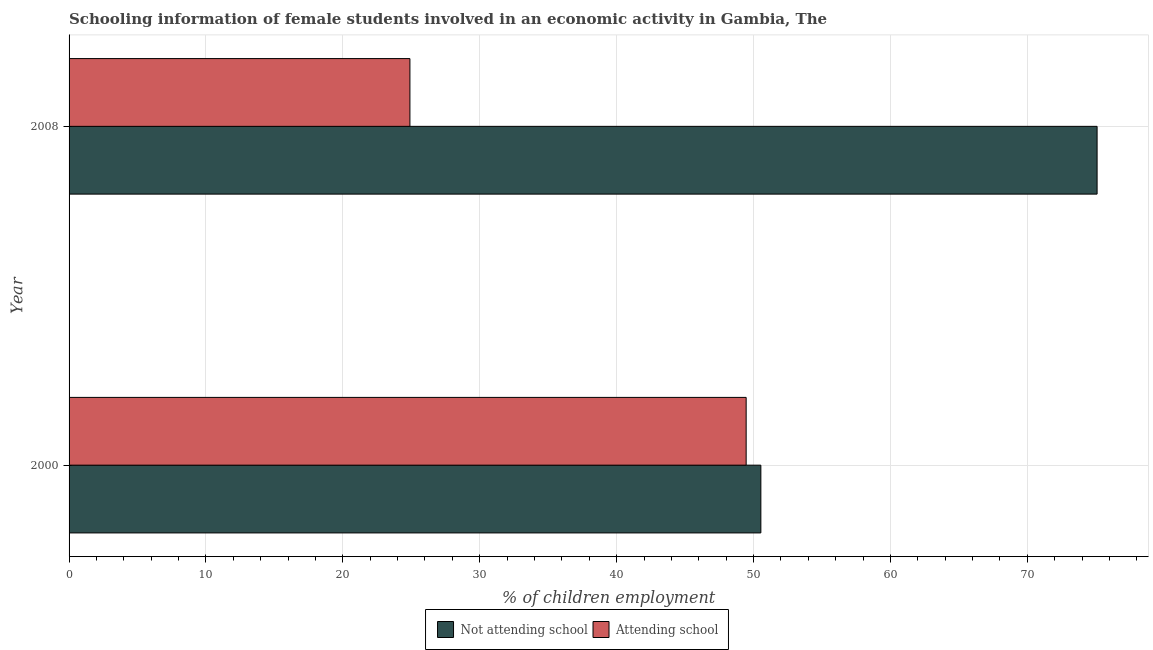How many different coloured bars are there?
Keep it short and to the point. 2. Are the number of bars on each tick of the Y-axis equal?
Offer a very short reply. Yes. How many bars are there on the 1st tick from the top?
Ensure brevity in your answer.  2. In how many cases, is the number of bars for a given year not equal to the number of legend labels?
Provide a short and direct response. 0. What is the percentage of employed females who are attending school in 2000?
Offer a terse response. 49.46. Across all years, what is the maximum percentage of employed females who are attending school?
Give a very brief answer. 49.46. Across all years, what is the minimum percentage of employed females who are not attending school?
Provide a short and direct response. 50.54. In which year was the percentage of employed females who are not attending school maximum?
Offer a very short reply. 2008. In which year was the percentage of employed females who are attending school minimum?
Ensure brevity in your answer.  2008. What is the total percentage of employed females who are attending school in the graph?
Offer a very short reply. 74.36. What is the difference between the percentage of employed females who are not attending school in 2000 and that in 2008?
Provide a short and direct response. -24.56. What is the difference between the percentage of employed females who are not attending school in 2000 and the percentage of employed females who are attending school in 2008?
Make the answer very short. 25.64. What is the average percentage of employed females who are not attending school per year?
Provide a succinct answer. 62.82. In the year 2000, what is the difference between the percentage of employed females who are not attending school and percentage of employed females who are attending school?
Give a very brief answer. 1.07. What is the ratio of the percentage of employed females who are not attending school in 2000 to that in 2008?
Keep it short and to the point. 0.67. Is the difference between the percentage of employed females who are not attending school in 2000 and 2008 greater than the difference between the percentage of employed females who are attending school in 2000 and 2008?
Your response must be concise. No. In how many years, is the percentage of employed females who are not attending school greater than the average percentage of employed females who are not attending school taken over all years?
Provide a succinct answer. 1. What does the 1st bar from the top in 2008 represents?
Offer a very short reply. Attending school. What does the 1st bar from the bottom in 2008 represents?
Your answer should be compact. Not attending school. How many bars are there?
Provide a succinct answer. 4. Are all the bars in the graph horizontal?
Give a very brief answer. Yes. What is the difference between two consecutive major ticks on the X-axis?
Provide a succinct answer. 10. Are the values on the major ticks of X-axis written in scientific E-notation?
Your answer should be very brief. No. How many legend labels are there?
Ensure brevity in your answer.  2. How are the legend labels stacked?
Provide a succinct answer. Horizontal. What is the title of the graph?
Offer a terse response. Schooling information of female students involved in an economic activity in Gambia, The. Does "Urban" appear as one of the legend labels in the graph?
Your answer should be very brief. No. What is the label or title of the X-axis?
Ensure brevity in your answer.  % of children employment. What is the label or title of the Y-axis?
Make the answer very short. Year. What is the % of children employment in Not attending school in 2000?
Your response must be concise. 50.54. What is the % of children employment in Attending school in 2000?
Ensure brevity in your answer.  49.46. What is the % of children employment in Not attending school in 2008?
Your response must be concise. 75.1. What is the % of children employment of Attending school in 2008?
Offer a very short reply. 24.9. Across all years, what is the maximum % of children employment in Not attending school?
Give a very brief answer. 75.1. Across all years, what is the maximum % of children employment in Attending school?
Ensure brevity in your answer.  49.46. Across all years, what is the minimum % of children employment in Not attending school?
Offer a very short reply. 50.54. Across all years, what is the minimum % of children employment in Attending school?
Make the answer very short. 24.9. What is the total % of children employment of Not attending school in the graph?
Your response must be concise. 125.64. What is the total % of children employment in Attending school in the graph?
Keep it short and to the point. 74.36. What is the difference between the % of children employment of Not attending school in 2000 and that in 2008?
Ensure brevity in your answer.  -24.56. What is the difference between the % of children employment of Attending school in 2000 and that in 2008?
Your answer should be very brief. 24.56. What is the difference between the % of children employment of Not attending school in 2000 and the % of children employment of Attending school in 2008?
Your answer should be compact. 25.64. What is the average % of children employment of Not attending school per year?
Offer a very short reply. 62.82. What is the average % of children employment of Attending school per year?
Offer a very short reply. 37.18. In the year 2000, what is the difference between the % of children employment of Not attending school and % of children employment of Attending school?
Make the answer very short. 1.07. In the year 2008, what is the difference between the % of children employment of Not attending school and % of children employment of Attending school?
Your answer should be compact. 50.2. What is the ratio of the % of children employment of Not attending school in 2000 to that in 2008?
Make the answer very short. 0.67. What is the ratio of the % of children employment in Attending school in 2000 to that in 2008?
Offer a terse response. 1.99. What is the difference between the highest and the second highest % of children employment in Not attending school?
Give a very brief answer. 24.56. What is the difference between the highest and the second highest % of children employment in Attending school?
Offer a terse response. 24.56. What is the difference between the highest and the lowest % of children employment in Not attending school?
Give a very brief answer. 24.56. What is the difference between the highest and the lowest % of children employment of Attending school?
Keep it short and to the point. 24.56. 